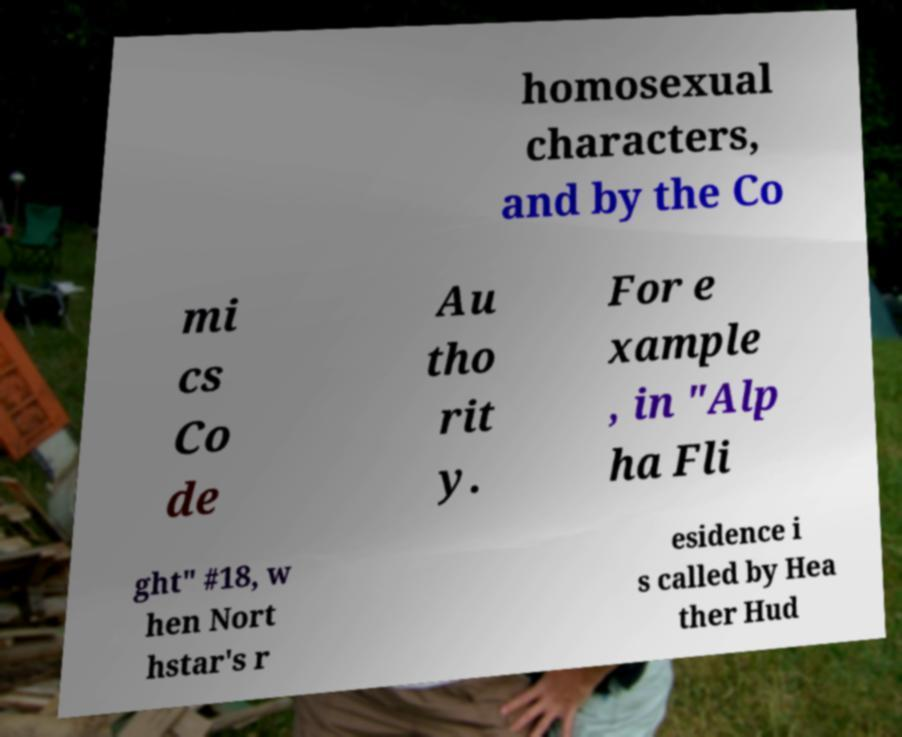Can you accurately transcribe the text from the provided image for me? homosexual characters, and by the Co mi cs Co de Au tho rit y. For e xample , in "Alp ha Fli ght" #18, w hen Nort hstar's r esidence i s called by Hea ther Hud 